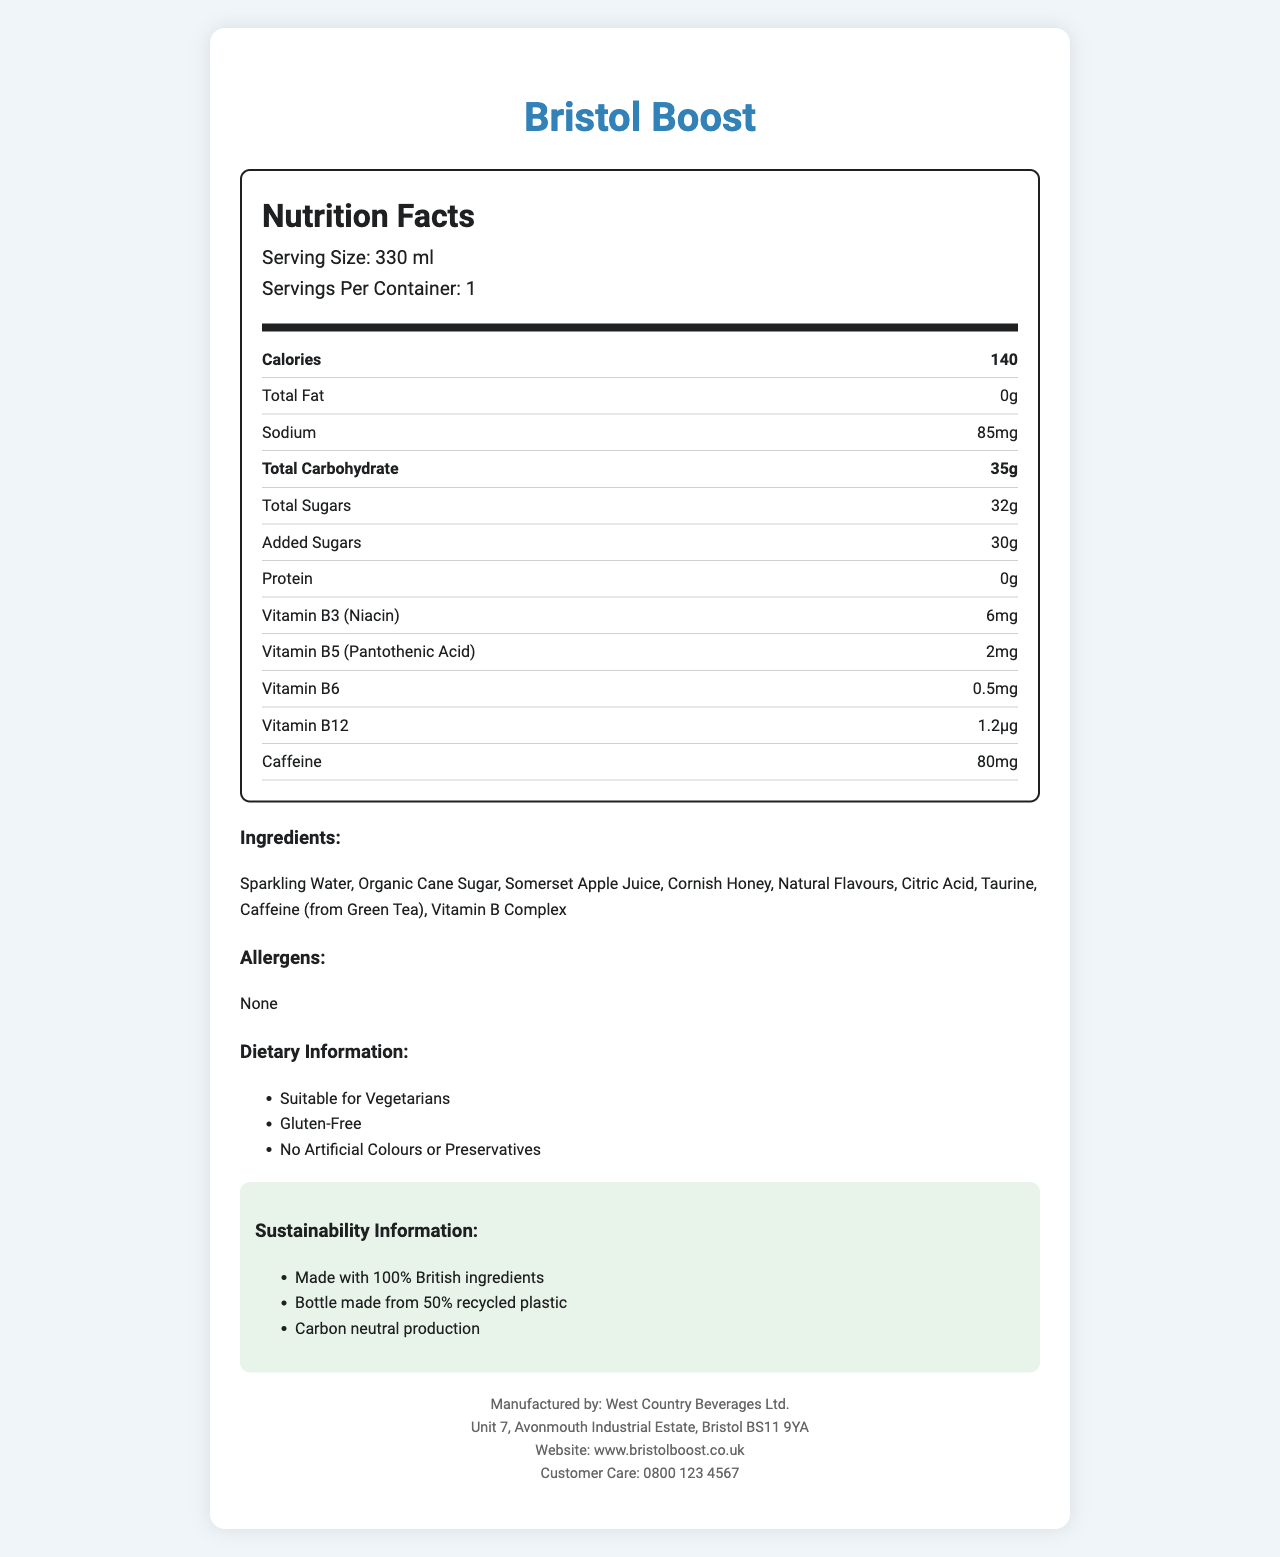what is the serving size of Bristol Boost? The serving size is listed at the beginning of the nutrition facts section.
Answer: 330 ml how many calories are in a serving? The calorie count is prominently displayed under the nutrition facts.
Answer: 140 calories what is the total carbohydrate content? The total carbohydrate is recorded in the nutrition facts.
Answer: 35g what are the ingredients in Bristol Boost? The ingredients list is detailed in the document.
Answer: Sparkling Water, Organic Cane Sugar, Somerset Apple Juice, Cornish Honey, Natural Flavours, Citric Acid, Taurine, Caffeine (from Green Tea), Vitamin B Complex how much added sugar is there in the energy drink? The quantity of added sugars is listed under the total sugars section.
Answer: 30g which vitamin has the highest quantity present in Bristol Boost? A. Vitamin B3 B. Vitamin B5 C. Vitamin B6 D. Vitamin B12 Vitamin B3 (Niacin) has the highest quantity at 6mg, compared to Vitamin B5 (2mg), Vitamin B6 (0.5mg), and Vitamin B12 (1.2µg).
Answer: A. Vitamin B3 which of the following is true about Bristol Boost's dietary information? 1. Contains preservatives 2. Suitable for vegetarians 3. Made with 100% recycled plastic 4. Contains gluten The document states that it is "Suitable for Vegetarians" and "Gluten-Free".
Answer: 2. Suitable for vegetarians is there any protein in Bristol Boost? The nutrition facts section shows there is 0g of protein.
Answer: No summarize the main details of Bristol Boost. The summary captures key nutritional information, ingredients, dietary details, sustainability efforts, and manufacturer information from the document.
Answer: Bristol Boost is a locally-sourced energy drink that contains 140 calories per 330 ml serving, with nutrients such as 35g of total carbohydrates and 32g of total sugars. It includes various B-vitamins and 80mg of caffeine. It's made with 100% British ingredients, is suitable for vegetarians, gluten-free, and has sustainable packaging. The drink is manufactured by West Country Beverages Ltd. what is the address of the manufacturer? The manufacturer’s address is listed at the bottom of the document.
Answer: Unit 7, Avonmouth Industrial Estate, Bristol BS11 9YA how much sodium is in a serving of Bristol Boost? The sodium content is clearly listed in the nutrition facts.
Answer: 85mg are any allergens mentioned? The document specifically states "None" under allergens.
Answer: None what is the source of caffeine in Bristol Boost? The ingredients list includes "Caffeine (from Green Tea)".
Answer: Green Tea Does Bristol Boost contain artificial colours? The document states "No Artificial Colours or Preservatives".
Answer: No how many servings does each container of Bristol Boost provide? The document specifies that there is 1 serving per container.
Answer: 1 what percentage of the bottle is made from recycled plastic? The sustainability information mentions that the bottle is made from 50% recycled plastic.
Answer: 50% what is the customer care line for Bristol Boost? The customer care line is listed at the bottom of the document.
Answer: 0800 123 4567 what percentage of the daily recommended intake of B-vitamins does Bristol Boost provide? The document provides the amounts of B-vitamins in milligrams and micrograms, but does not offer the daily percentage values.
Answer: Cannot be determined 